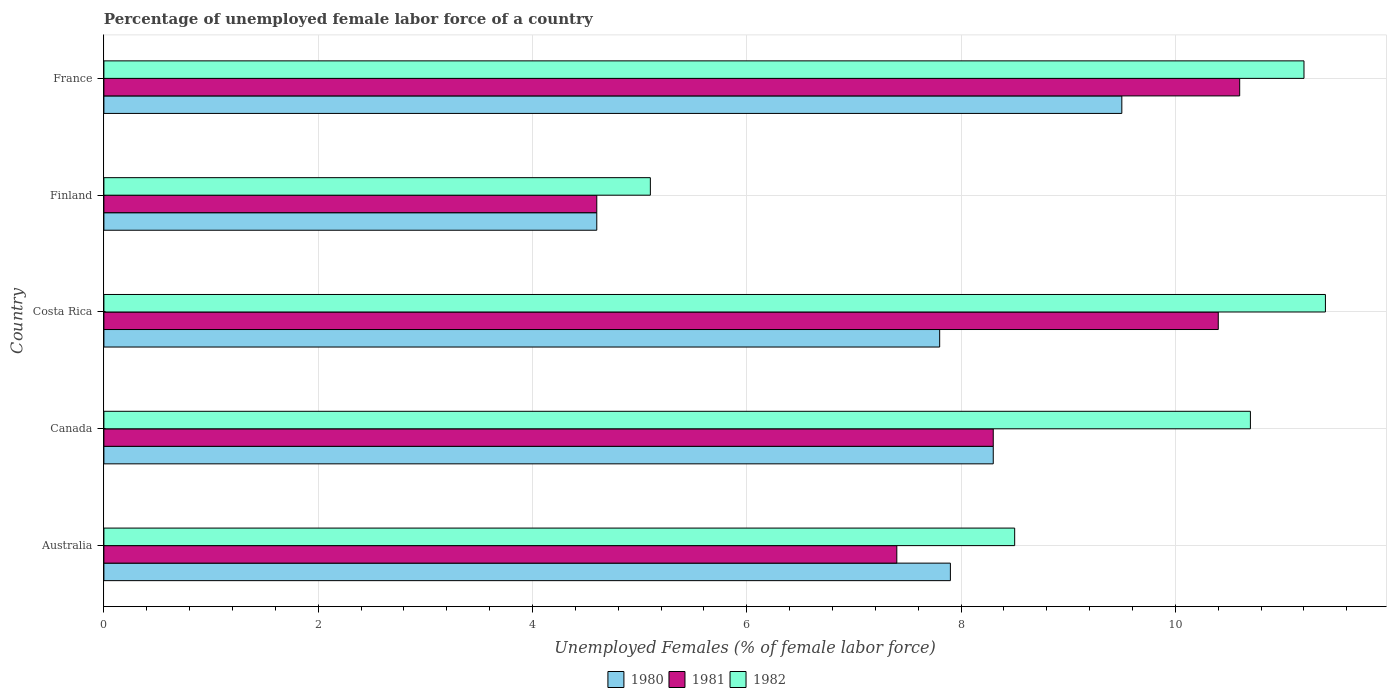How many groups of bars are there?
Your response must be concise. 5. How many bars are there on the 3rd tick from the top?
Provide a succinct answer. 3. What is the percentage of unemployed female labor force in 1982 in Costa Rica?
Make the answer very short. 11.4. Across all countries, what is the maximum percentage of unemployed female labor force in 1982?
Your response must be concise. 11.4. Across all countries, what is the minimum percentage of unemployed female labor force in 1981?
Your response must be concise. 4.6. In which country was the percentage of unemployed female labor force in 1981 maximum?
Your answer should be compact. France. In which country was the percentage of unemployed female labor force in 1981 minimum?
Ensure brevity in your answer.  Finland. What is the total percentage of unemployed female labor force in 1981 in the graph?
Your answer should be compact. 41.3. What is the difference between the percentage of unemployed female labor force in 1981 in Australia and that in Canada?
Your answer should be compact. -0.9. What is the difference between the percentage of unemployed female labor force in 1982 in Canada and the percentage of unemployed female labor force in 1980 in Finland?
Your answer should be very brief. 6.1. What is the average percentage of unemployed female labor force in 1981 per country?
Give a very brief answer. 8.26. What is the ratio of the percentage of unemployed female labor force in 1981 in Canada to that in Costa Rica?
Offer a very short reply. 0.8. Is the percentage of unemployed female labor force in 1982 in Canada less than that in Costa Rica?
Provide a succinct answer. Yes. What is the difference between the highest and the second highest percentage of unemployed female labor force in 1981?
Your answer should be compact. 0.2. What is the difference between the highest and the lowest percentage of unemployed female labor force in 1981?
Offer a very short reply. 6. In how many countries, is the percentage of unemployed female labor force in 1981 greater than the average percentage of unemployed female labor force in 1981 taken over all countries?
Offer a terse response. 3. What does the 3rd bar from the top in Canada represents?
Your answer should be very brief. 1980. What is the difference between two consecutive major ticks on the X-axis?
Ensure brevity in your answer.  2. Are the values on the major ticks of X-axis written in scientific E-notation?
Your response must be concise. No. How are the legend labels stacked?
Provide a short and direct response. Horizontal. What is the title of the graph?
Offer a terse response. Percentage of unemployed female labor force of a country. Does "1993" appear as one of the legend labels in the graph?
Make the answer very short. No. What is the label or title of the X-axis?
Offer a very short reply. Unemployed Females (% of female labor force). What is the label or title of the Y-axis?
Offer a terse response. Country. What is the Unemployed Females (% of female labor force) of 1980 in Australia?
Your answer should be compact. 7.9. What is the Unemployed Females (% of female labor force) in 1981 in Australia?
Keep it short and to the point. 7.4. What is the Unemployed Females (% of female labor force) of 1982 in Australia?
Your answer should be compact. 8.5. What is the Unemployed Females (% of female labor force) of 1980 in Canada?
Give a very brief answer. 8.3. What is the Unemployed Females (% of female labor force) of 1981 in Canada?
Your response must be concise. 8.3. What is the Unemployed Females (% of female labor force) in 1982 in Canada?
Your answer should be compact. 10.7. What is the Unemployed Females (% of female labor force) in 1980 in Costa Rica?
Keep it short and to the point. 7.8. What is the Unemployed Females (% of female labor force) in 1981 in Costa Rica?
Your answer should be compact. 10.4. What is the Unemployed Females (% of female labor force) of 1982 in Costa Rica?
Your answer should be compact. 11.4. What is the Unemployed Females (% of female labor force) in 1980 in Finland?
Your answer should be very brief. 4.6. What is the Unemployed Females (% of female labor force) in 1981 in Finland?
Keep it short and to the point. 4.6. What is the Unemployed Females (% of female labor force) of 1982 in Finland?
Your answer should be compact. 5.1. What is the Unemployed Females (% of female labor force) of 1980 in France?
Offer a very short reply. 9.5. What is the Unemployed Females (% of female labor force) in 1981 in France?
Offer a very short reply. 10.6. What is the Unemployed Females (% of female labor force) in 1982 in France?
Your answer should be compact. 11.2. Across all countries, what is the maximum Unemployed Females (% of female labor force) in 1981?
Offer a very short reply. 10.6. Across all countries, what is the maximum Unemployed Females (% of female labor force) of 1982?
Your answer should be very brief. 11.4. Across all countries, what is the minimum Unemployed Females (% of female labor force) of 1980?
Provide a short and direct response. 4.6. Across all countries, what is the minimum Unemployed Females (% of female labor force) in 1981?
Offer a very short reply. 4.6. Across all countries, what is the minimum Unemployed Females (% of female labor force) in 1982?
Offer a terse response. 5.1. What is the total Unemployed Females (% of female labor force) of 1980 in the graph?
Offer a very short reply. 38.1. What is the total Unemployed Females (% of female labor force) of 1981 in the graph?
Your response must be concise. 41.3. What is the total Unemployed Females (% of female labor force) of 1982 in the graph?
Provide a short and direct response. 46.9. What is the difference between the Unemployed Females (% of female labor force) in 1980 in Australia and that in Canada?
Ensure brevity in your answer.  -0.4. What is the difference between the Unemployed Females (% of female labor force) of 1982 in Australia and that in Canada?
Your answer should be very brief. -2.2. What is the difference between the Unemployed Females (% of female labor force) of 1980 in Australia and that in Costa Rica?
Give a very brief answer. 0.1. What is the difference between the Unemployed Females (% of female labor force) in 1981 in Australia and that in Costa Rica?
Provide a short and direct response. -3. What is the difference between the Unemployed Females (% of female labor force) in 1980 in Australia and that in Finland?
Keep it short and to the point. 3.3. What is the difference between the Unemployed Females (% of female labor force) of 1981 in Australia and that in Finland?
Your answer should be very brief. 2.8. What is the difference between the Unemployed Females (% of female labor force) of 1982 in Australia and that in Finland?
Provide a short and direct response. 3.4. What is the difference between the Unemployed Females (% of female labor force) of 1980 in Australia and that in France?
Offer a very short reply. -1.6. What is the difference between the Unemployed Females (% of female labor force) of 1982 in Australia and that in France?
Offer a very short reply. -2.7. What is the difference between the Unemployed Females (% of female labor force) of 1980 in Canada and that in Finland?
Ensure brevity in your answer.  3.7. What is the difference between the Unemployed Females (% of female labor force) of 1982 in Canada and that in Finland?
Your answer should be compact. 5.6. What is the difference between the Unemployed Females (% of female labor force) of 1980 in Canada and that in France?
Keep it short and to the point. -1.2. What is the difference between the Unemployed Females (% of female labor force) in 1980 in Costa Rica and that in Finland?
Ensure brevity in your answer.  3.2. What is the difference between the Unemployed Females (% of female labor force) of 1982 in Costa Rica and that in Finland?
Keep it short and to the point. 6.3. What is the difference between the Unemployed Females (% of female labor force) in 1980 in Costa Rica and that in France?
Offer a very short reply. -1.7. What is the difference between the Unemployed Females (% of female labor force) in 1980 in Finland and that in France?
Keep it short and to the point. -4.9. What is the difference between the Unemployed Females (% of female labor force) in 1981 in Australia and the Unemployed Females (% of female labor force) in 1982 in Costa Rica?
Offer a terse response. -4. What is the difference between the Unemployed Females (% of female labor force) in 1980 in Australia and the Unemployed Females (% of female labor force) in 1981 in Finland?
Ensure brevity in your answer.  3.3. What is the difference between the Unemployed Females (% of female labor force) in 1980 in Australia and the Unemployed Females (% of female labor force) in 1982 in Finland?
Your answer should be compact. 2.8. What is the difference between the Unemployed Females (% of female labor force) of 1981 in Australia and the Unemployed Females (% of female labor force) of 1982 in Finland?
Make the answer very short. 2.3. What is the difference between the Unemployed Females (% of female labor force) of 1980 in Australia and the Unemployed Females (% of female labor force) of 1981 in France?
Your response must be concise. -2.7. What is the difference between the Unemployed Females (% of female labor force) in 1981 in Australia and the Unemployed Females (% of female labor force) in 1982 in France?
Provide a succinct answer. -3.8. What is the difference between the Unemployed Females (% of female labor force) in 1980 in Canada and the Unemployed Females (% of female labor force) in 1982 in Costa Rica?
Offer a terse response. -3.1. What is the difference between the Unemployed Females (% of female labor force) of 1981 in Canada and the Unemployed Females (% of female labor force) of 1982 in Finland?
Your answer should be very brief. 3.2. What is the difference between the Unemployed Females (% of female labor force) in 1980 in Canada and the Unemployed Females (% of female labor force) in 1981 in France?
Offer a very short reply. -2.3. What is the difference between the Unemployed Females (% of female labor force) of 1980 in Costa Rica and the Unemployed Females (% of female labor force) of 1981 in France?
Your answer should be very brief. -2.8. What is the difference between the Unemployed Females (% of female labor force) in 1980 in Costa Rica and the Unemployed Females (% of female labor force) in 1982 in France?
Offer a terse response. -3.4. What is the difference between the Unemployed Females (% of female labor force) of 1981 in Costa Rica and the Unemployed Females (% of female labor force) of 1982 in France?
Your answer should be very brief. -0.8. What is the difference between the Unemployed Females (% of female labor force) in 1980 in Finland and the Unemployed Females (% of female labor force) in 1982 in France?
Provide a short and direct response. -6.6. What is the average Unemployed Females (% of female labor force) of 1980 per country?
Your response must be concise. 7.62. What is the average Unemployed Females (% of female labor force) in 1981 per country?
Your response must be concise. 8.26. What is the average Unemployed Females (% of female labor force) of 1982 per country?
Make the answer very short. 9.38. What is the difference between the Unemployed Females (% of female labor force) of 1980 and Unemployed Females (% of female labor force) of 1981 in Australia?
Your answer should be compact. 0.5. What is the difference between the Unemployed Females (% of female labor force) in 1980 and Unemployed Females (% of female labor force) in 1982 in Australia?
Offer a terse response. -0.6. What is the difference between the Unemployed Females (% of female labor force) of 1981 and Unemployed Females (% of female labor force) of 1982 in Australia?
Your response must be concise. -1.1. What is the difference between the Unemployed Females (% of female labor force) in 1980 and Unemployed Females (% of female labor force) in 1982 in Canada?
Provide a short and direct response. -2.4. What is the difference between the Unemployed Females (% of female labor force) in 1981 and Unemployed Females (% of female labor force) in 1982 in Canada?
Offer a terse response. -2.4. What is the ratio of the Unemployed Females (% of female labor force) in 1980 in Australia to that in Canada?
Your answer should be very brief. 0.95. What is the ratio of the Unemployed Females (% of female labor force) in 1981 in Australia to that in Canada?
Your answer should be very brief. 0.89. What is the ratio of the Unemployed Females (% of female labor force) in 1982 in Australia to that in Canada?
Provide a succinct answer. 0.79. What is the ratio of the Unemployed Females (% of female labor force) of 1980 in Australia to that in Costa Rica?
Your answer should be compact. 1.01. What is the ratio of the Unemployed Females (% of female labor force) in 1981 in Australia to that in Costa Rica?
Offer a very short reply. 0.71. What is the ratio of the Unemployed Females (% of female labor force) in 1982 in Australia to that in Costa Rica?
Your answer should be very brief. 0.75. What is the ratio of the Unemployed Females (% of female labor force) of 1980 in Australia to that in Finland?
Your answer should be very brief. 1.72. What is the ratio of the Unemployed Females (% of female labor force) in 1981 in Australia to that in Finland?
Your answer should be very brief. 1.61. What is the ratio of the Unemployed Females (% of female labor force) in 1980 in Australia to that in France?
Offer a terse response. 0.83. What is the ratio of the Unemployed Females (% of female labor force) of 1981 in Australia to that in France?
Your answer should be compact. 0.7. What is the ratio of the Unemployed Females (% of female labor force) in 1982 in Australia to that in France?
Give a very brief answer. 0.76. What is the ratio of the Unemployed Females (% of female labor force) in 1980 in Canada to that in Costa Rica?
Ensure brevity in your answer.  1.06. What is the ratio of the Unemployed Females (% of female labor force) of 1981 in Canada to that in Costa Rica?
Make the answer very short. 0.8. What is the ratio of the Unemployed Females (% of female labor force) of 1982 in Canada to that in Costa Rica?
Offer a terse response. 0.94. What is the ratio of the Unemployed Females (% of female labor force) in 1980 in Canada to that in Finland?
Give a very brief answer. 1.8. What is the ratio of the Unemployed Females (% of female labor force) in 1981 in Canada to that in Finland?
Your response must be concise. 1.8. What is the ratio of the Unemployed Females (% of female labor force) of 1982 in Canada to that in Finland?
Provide a short and direct response. 2.1. What is the ratio of the Unemployed Females (% of female labor force) of 1980 in Canada to that in France?
Offer a terse response. 0.87. What is the ratio of the Unemployed Females (% of female labor force) of 1981 in Canada to that in France?
Offer a very short reply. 0.78. What is the ratio of the Unemployed Females (% of female labor force) of 1982 in Canada to that in France?
Provide a short and direct response. 0.96. What is the ratio of the Unemployed Females (% of female labor force) in 1980 in Costa Rica to that in Finland?
Provide a short and direct response. 1.7. What is the ratio of the Unemployed Females (% of female labor force) of 1981 in Costa Rica to that in Finland?
Provide a short and direct response. 2.26. What is the ratio of the Unemployed Females (% of female labor force) in 1982 in Costa Rica to that in Finland?
Offer a very short reply. 2.24. What is the ratio of the Unemployed Females (% of female labor force) in 1980 in Costa Rica to that in France?
Make the answer very short. 0.82. What is the ratio of the Unemployed Females (% of female labor force) in 1981 in Costa Rica to that in France?
Make the answer very short. 0.98. What is the ratio of the Unemployed Females (% of female labor force) of 1982 in Costa Rica to that in France?
Keep it short and to the point. 1.02. What is the ratio of the Unemployed Females (% of female labor force) of 1980 in Finland to that in France?
Provide a succinct answer. 0.48. What is the ratio of the Unemployed Females (% of female labor force) of 1981 in Finland to that in France?
Offer a very short reply. 0.43. What is the ratio of the Unemployed Females (% of female labor force) in 1982 in Finland to that in France?
Your response must be concise. 0.46. What is the difference between the highest and the second highest Unemployed Females (% of female labor force) in 1982?
Your response must be concise. 0.2. What is the difference between the highest and the lowest Unemployed Females (% of female labor force) of 1980?
Offer a terse response. 4.9. What is the difference between the highest and the lowest Unemployed Females (% of female labor force) in 1981?
Your answer should be compact. 6. 